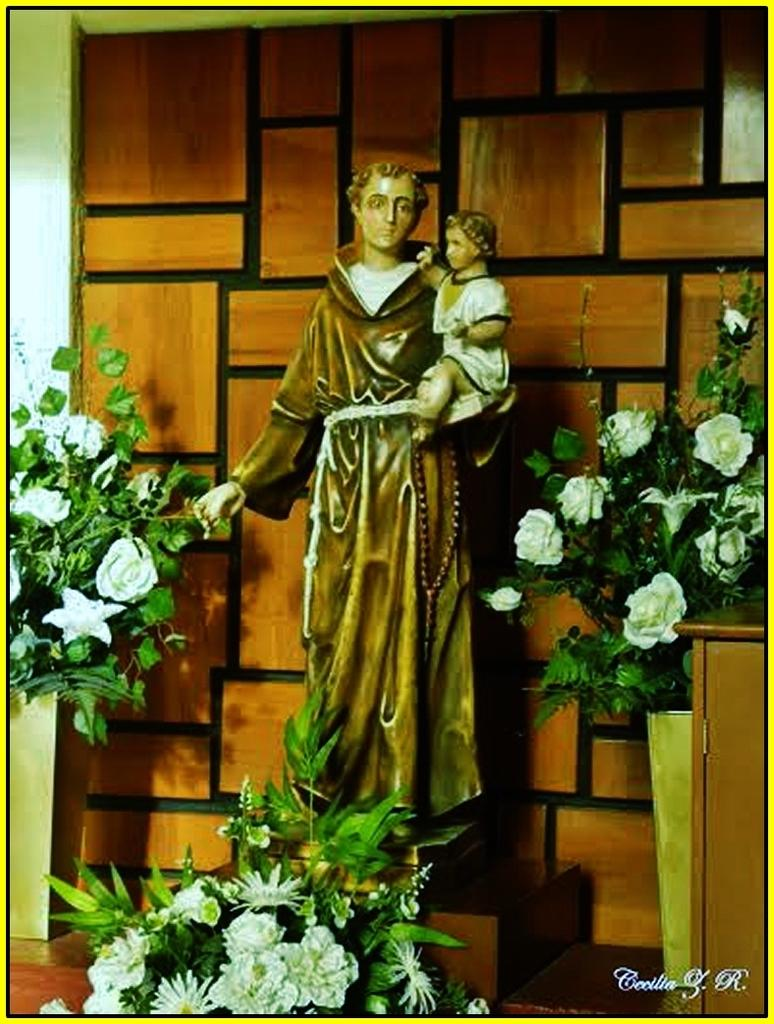What is the statue holding in the image? The statue is holding a baby in the image. What type of vegetation can be seen on the right side of the image? There are plants on the right side of the image. Can you describe the positioning of the plants on the right side? One plant is at the bottom on the right side, and another plant is on the left side of the image. Where is the mailbox located in the image? There is no mailbox present in the image. What type of parcel is being delivered by the statue in the image? The statue is not delivering a parcel; it is holding a baby. 